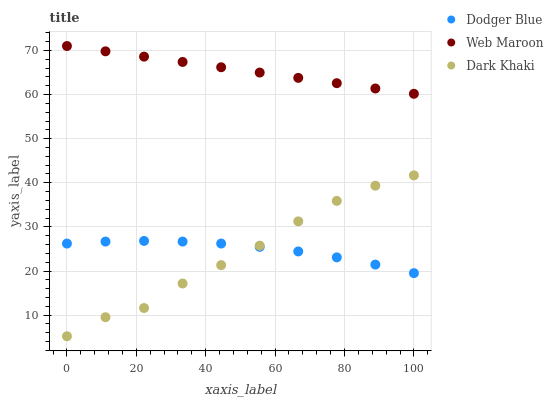Does Dark Khaki have the minimum area under the curve?
Answer yes or no. Yes. Does Web Maroon have the maximum area under the curve?
Answer yes or no. Yes. Does Dodger Blue have the minimum area under the curve?
Answer yes or no. No. Does Dodger Blue have the maximum area under the curve?
Answer yes or no. No. Is Web Maroon the smoothest?
Answer yes or no. Yes. Is Dark Khaki the roughest?
Answer yes or no. Yes. Is Dodger Blue the smoothest?
Answer yes or no. No. Is Dodger Blue the roughest?
Answer yes or no. No. Does Dark Khaki have the lowest value?
Answer yes or no. Yes. Does Dodger Blue have the lowest value?
Answer yes or no. No. Does Web Maroon have the highest value?
Answer yes or no. Yes. Does Dodger Blue have the highest value?
Answer yes or no. No. Is Dark Khaki less than Web Maroon?
Answer yes or no. Yes. Is Web Maroon greater than Dodger Blue?
Answer yes or no. Yes. Does Dark Khaki intersect Dodger Blue?
Answer yes or no. Yes. Is Dark Khaki less than Dodger Blue?
Answer yes or no. No. Is Dark Khaki greater than Dodger Blue?
Answer yes or no. No. Does Dark Khaki intersect Web Maroon?
Answer yes or no. No. 